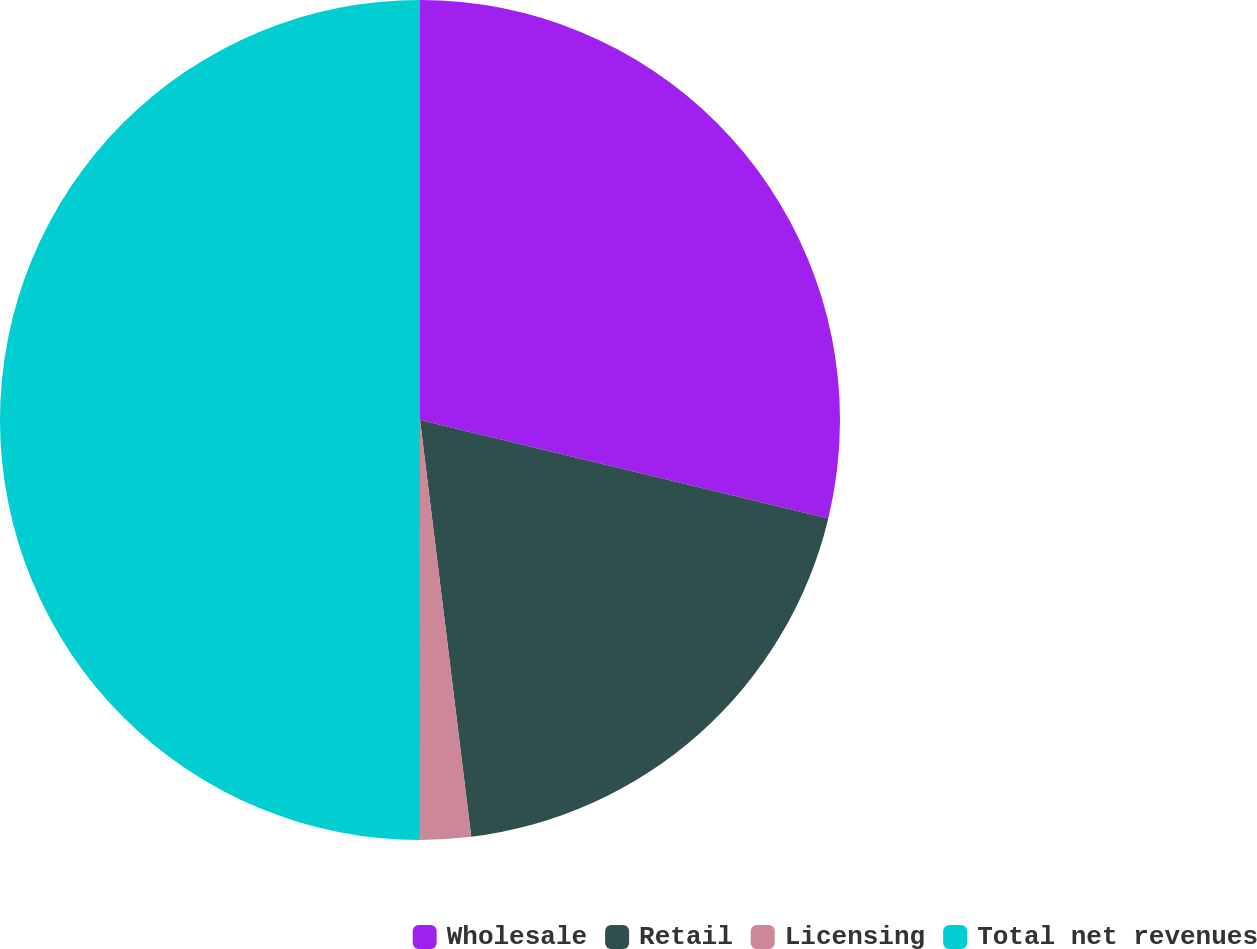Convert chart to OTSL. <chart><loc_0><loc_0><loc_500><loc_500><pie_chart><fcel>Wholesale<fcel>Retail<fcel>Licensing<fcel>Total net revenues<nl><fcel>28.76%<fcel>19.29%<fcel>1.94%<fcel>50.0%<nl></chart> 